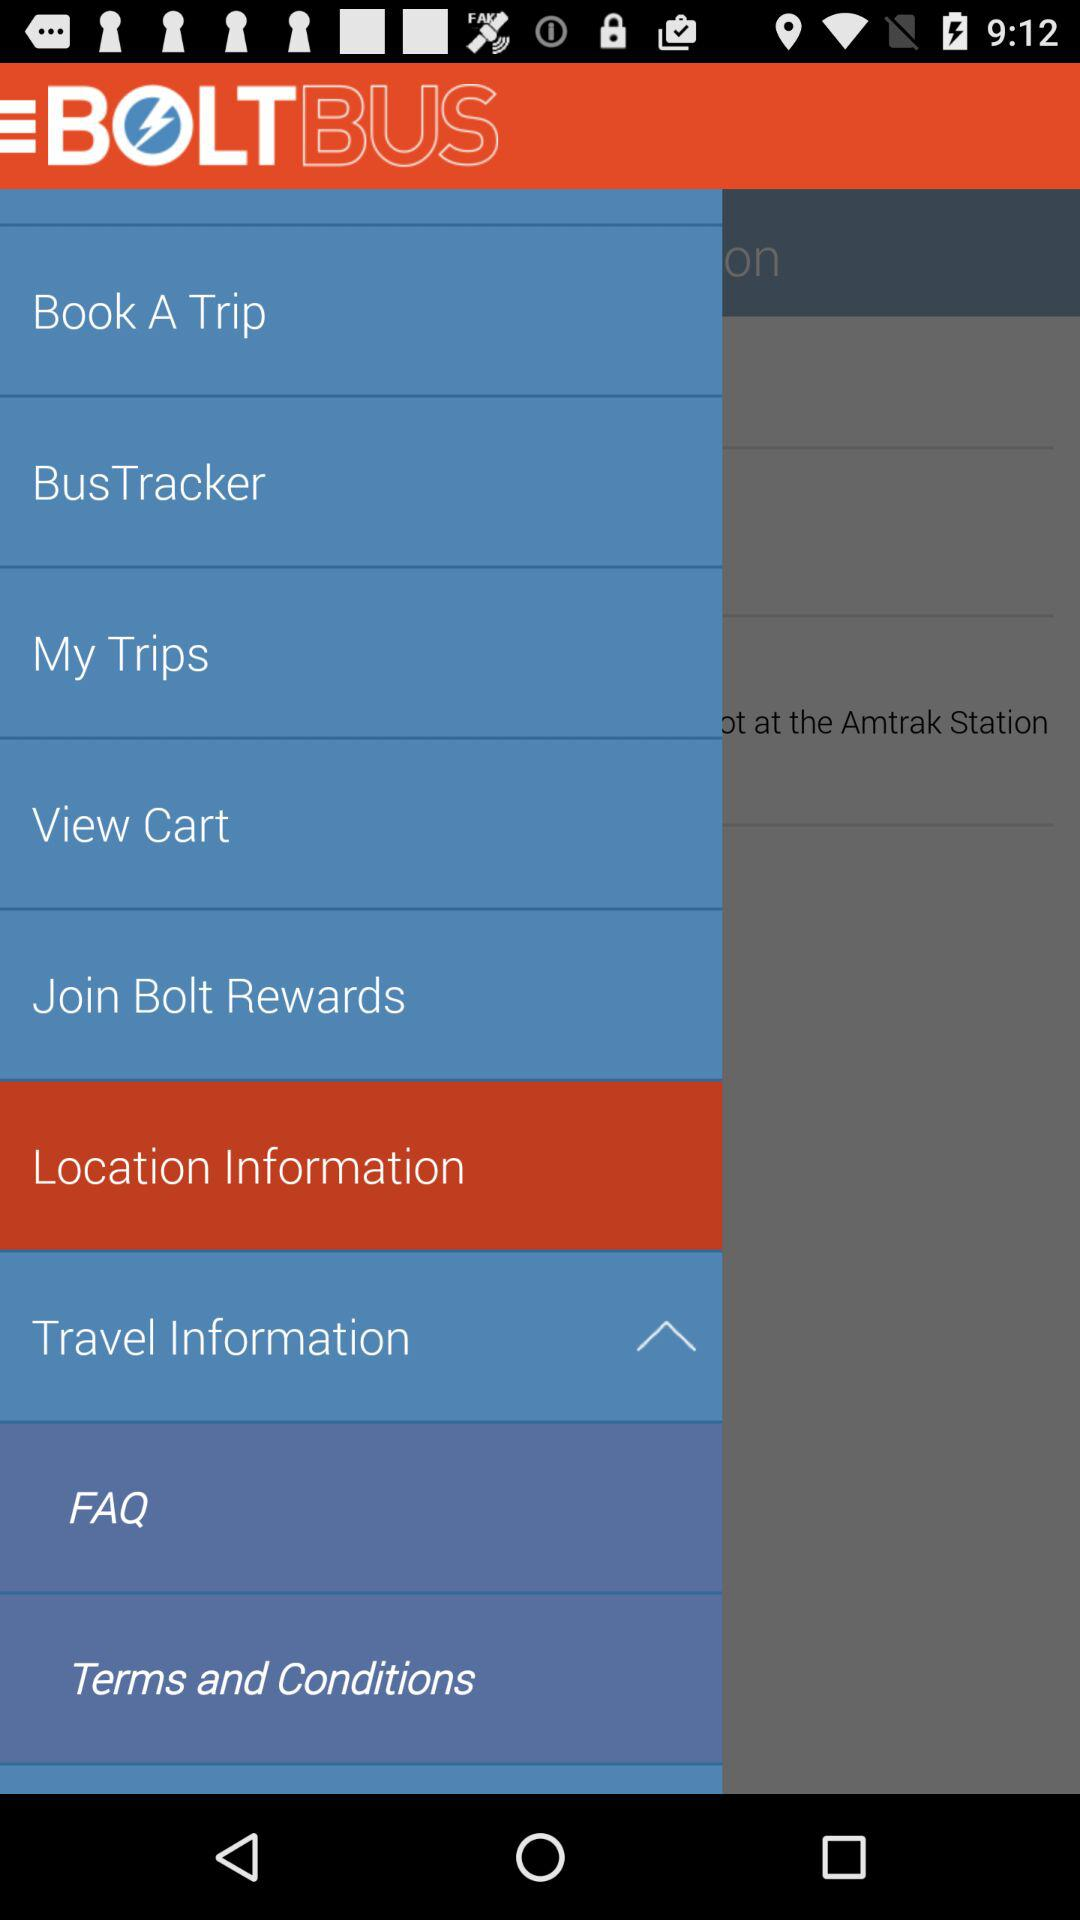What is the selected item? The selected item is "Location Information". 